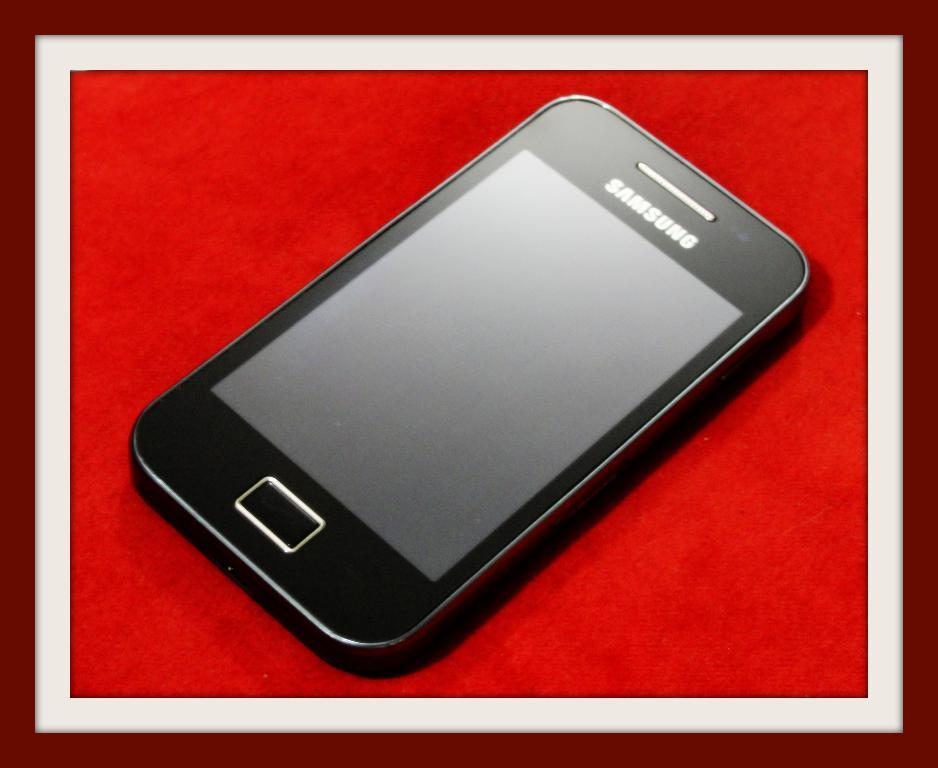<image>
Describe the image concisely. A black cell phone made by Samsung with a blank screen. 